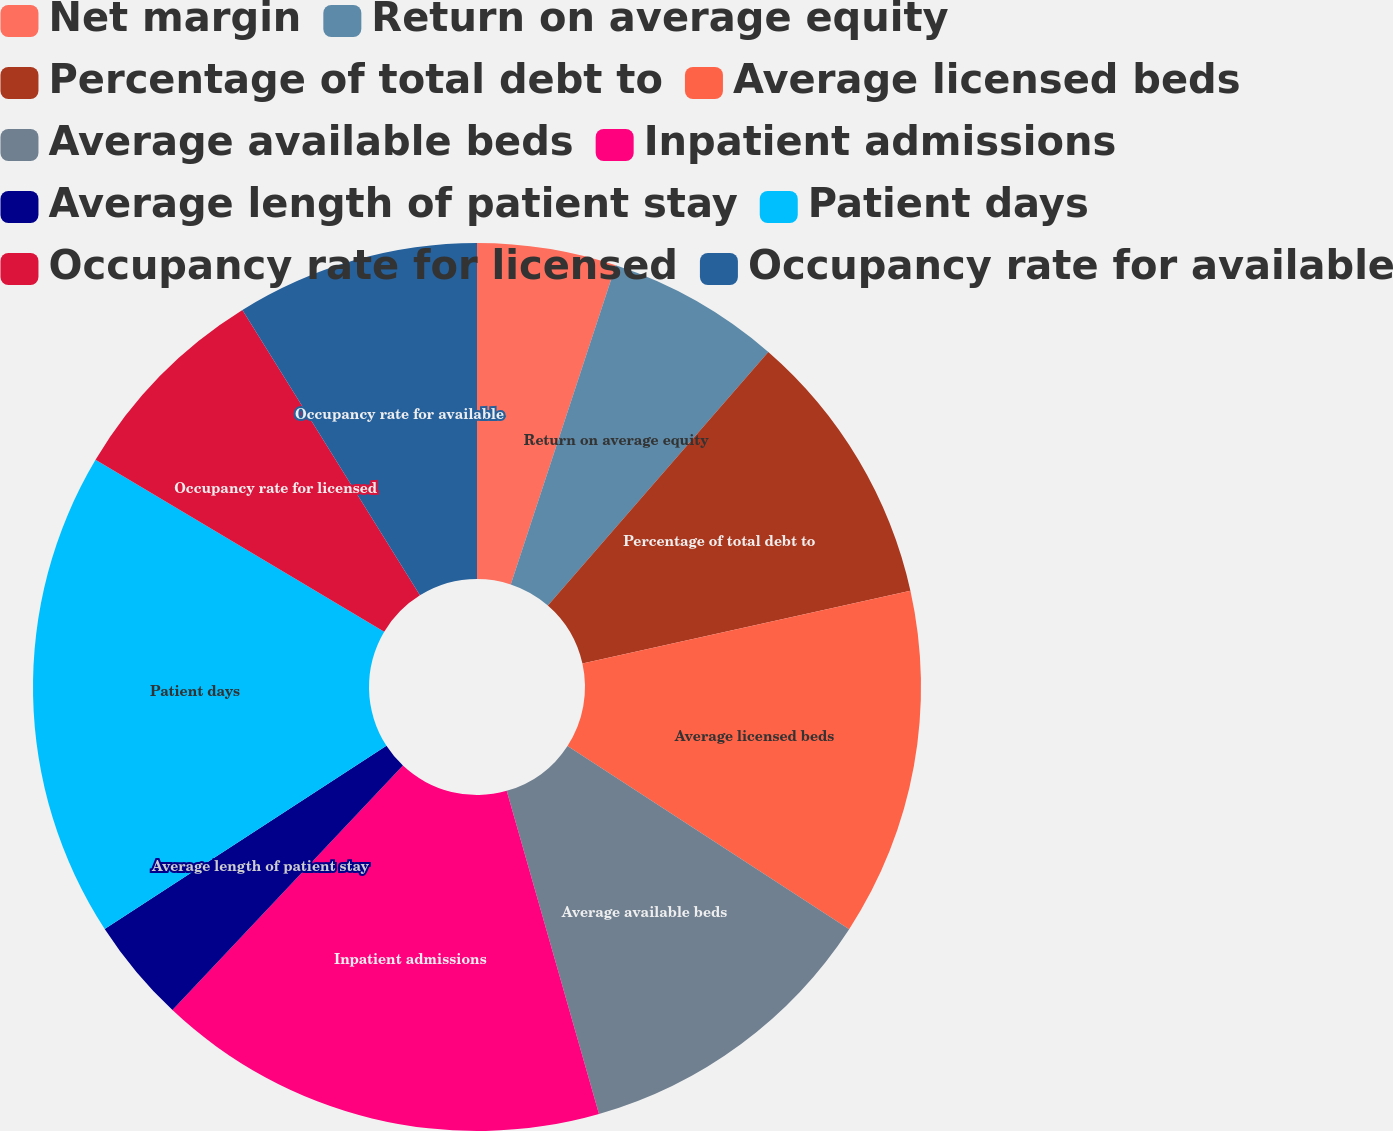Convert chart. <chart><loc_0><loc_0><loc_500><loc_500><pie_chart><fcel>Net margin<fcel>Return on average equity<fcel>Percentage of total debt to<fcel>Average licensed beds<fcel>Average available beds<fcel>Inpatient admissions<fcel>Average length of patient stay<fcel>Patient days<fcel>Occupancy rate for licensed<fcel>Occupancy rate for available<nl><fcel>5.06%<fcel>6.33%<fcel>10.13%<fcel>12.66%<fcel>11.39%<fcel>16.46%<fcel>3.8%<fcel>17.72%<fcel>7.59%<fcel>8.86%<nl></chart> 